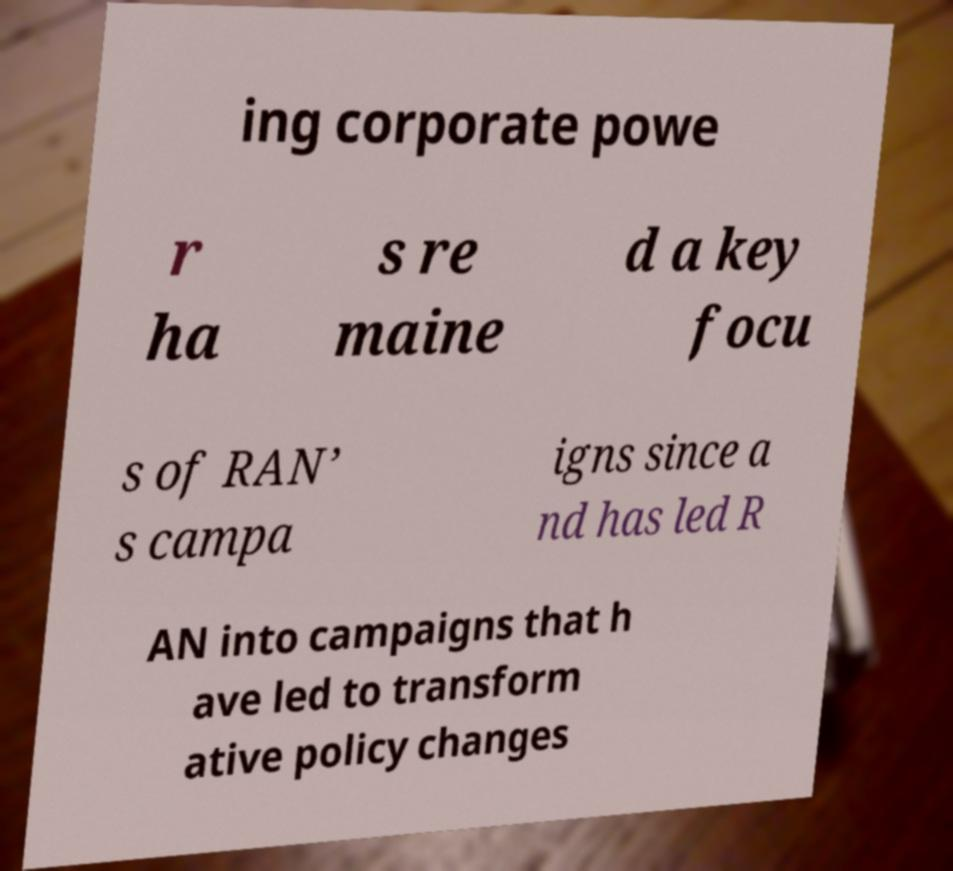There's text embedded in this image that I need extracted. Can you transcribe it verbatim? ing corporate powe r ha s re maine d a key focu s of RAN’ s campa igns since a nd has led R AN into campaigns that h ave led to transform ative policy changes 